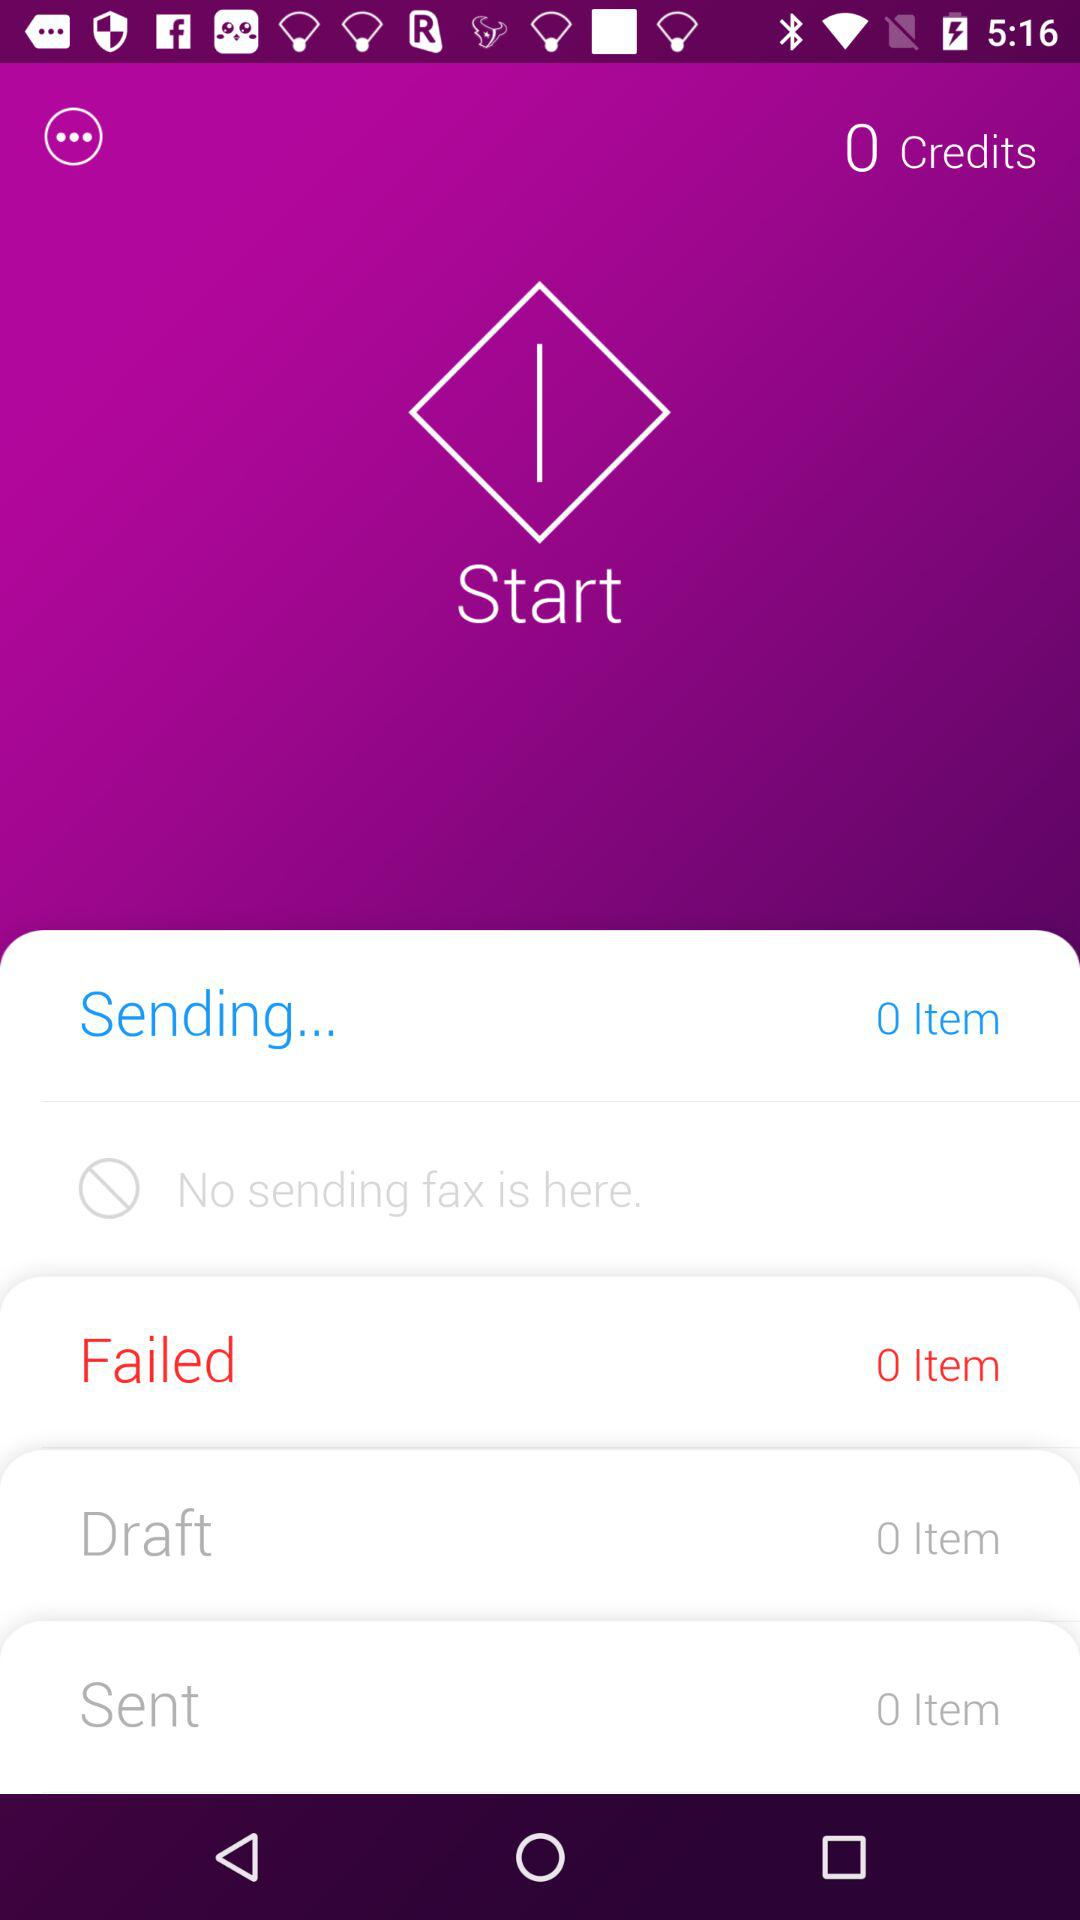How many credits are there in the account? There are 0 credits in the account. 